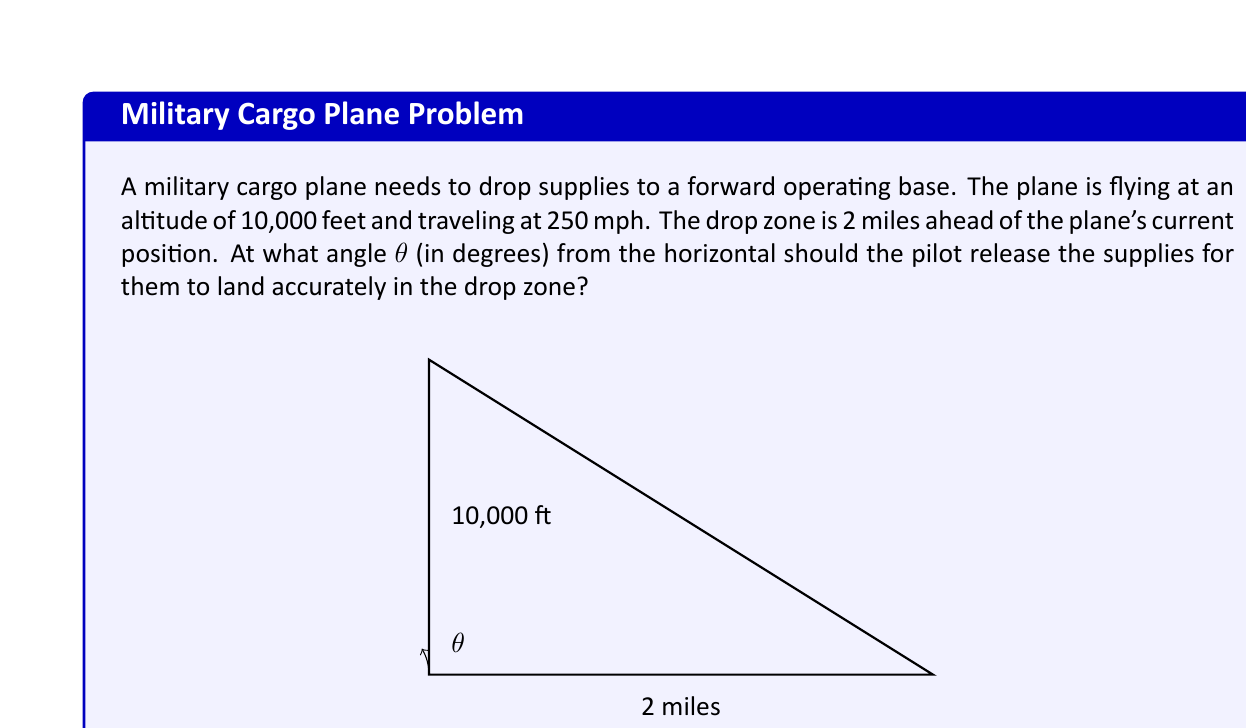Help me with this question. Let's approach this step-by-step:

1) First, we need to convert all measurements to the same units. Let's use feet:
   - Altitude: 10,000 feet
   - Distance to drop zone: 2 miles = 2 * 5280 = 10,560 feet

2) We can now visualize this as a right triangle, where:
   - The vertical side is 10,000 feet
   - The horizontal side is 10,560 feet
   - The angle we're looking for is at the plane's position

3) We can use the tangent function to find this angle:

   $$\tan(\theta) = \frac{\text{opposite}}{\text{adjacent}} = \frac{10,000}{10,560}$$

4) To solve for θ, we use the inverse tangent (arctan or $\tan^{-1}$):

   $$\theta = \tan^{-1}\left(\frac{10,000}{10,560}\right)$$

5) Using a calculator or computer:

   $$\theta \approx 43.47 \text{ degrees}$$

6) However, this angle would be correct if the plane were stationary. Since the plane is moving, we need to account for the forward motion of the plane during the drop.

7) The time it takes for the supplies to fall can be calculated using the equation:

   $$t = \sqrt{\frac{2h}{g}}$$

   where $h$ is the height and $g$ is the acceleration due to gravity (32.2 ft/s²)

   $$t = \sqrt{\frac{2 * 10,000}{32.2}} \approx 24.9 \text{ seconds}$$

8) In this time, the plane will travel:
   250 mph = 366.67 ft/s
   Distance = 366.67 * 24.9 ≈ 9,130 feet

9) Now our triangle has changed. The new horizontal distance is:
   10,560 - 9,130 = 1,430 feet

10) The new angle is:

    $$\theta = \tan^{-1}\left(\frac{10,000}{1,430}\right) \approx 81.85 \text{ degrees}$$

This is the angle at which the pilot should release the supplies for them to land in the drop zone, accounting for the plane's forward motion.
Answer: $\theta \approx 81.85 \text{ degrees}$ 